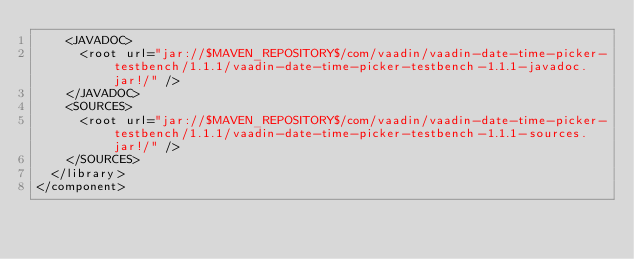Convert code to text. <code><loc_0><loc_0><loc_500><loc_500><_XML_>    <JAVADOC>
      <root url="jar://$MAVEN_REPOSITORY$/com/vaadin/vaadin-date-time-picker-testbench/1.1.1/vaadin-date-time-picker-testbench-1.1.1-javadoc.jar!/" />
    </JAVADOC>
    <SOURCES>
      <root url="jar://$MAVEN_REPOSITORY$/com/vaadin/vaadin-date-time-picker-testbench/1.1.1/vaadin-date-time-picker-testbench-1.1.1-sources.jar!/" />
    </SOURCES>
  </library>
</component></code> 